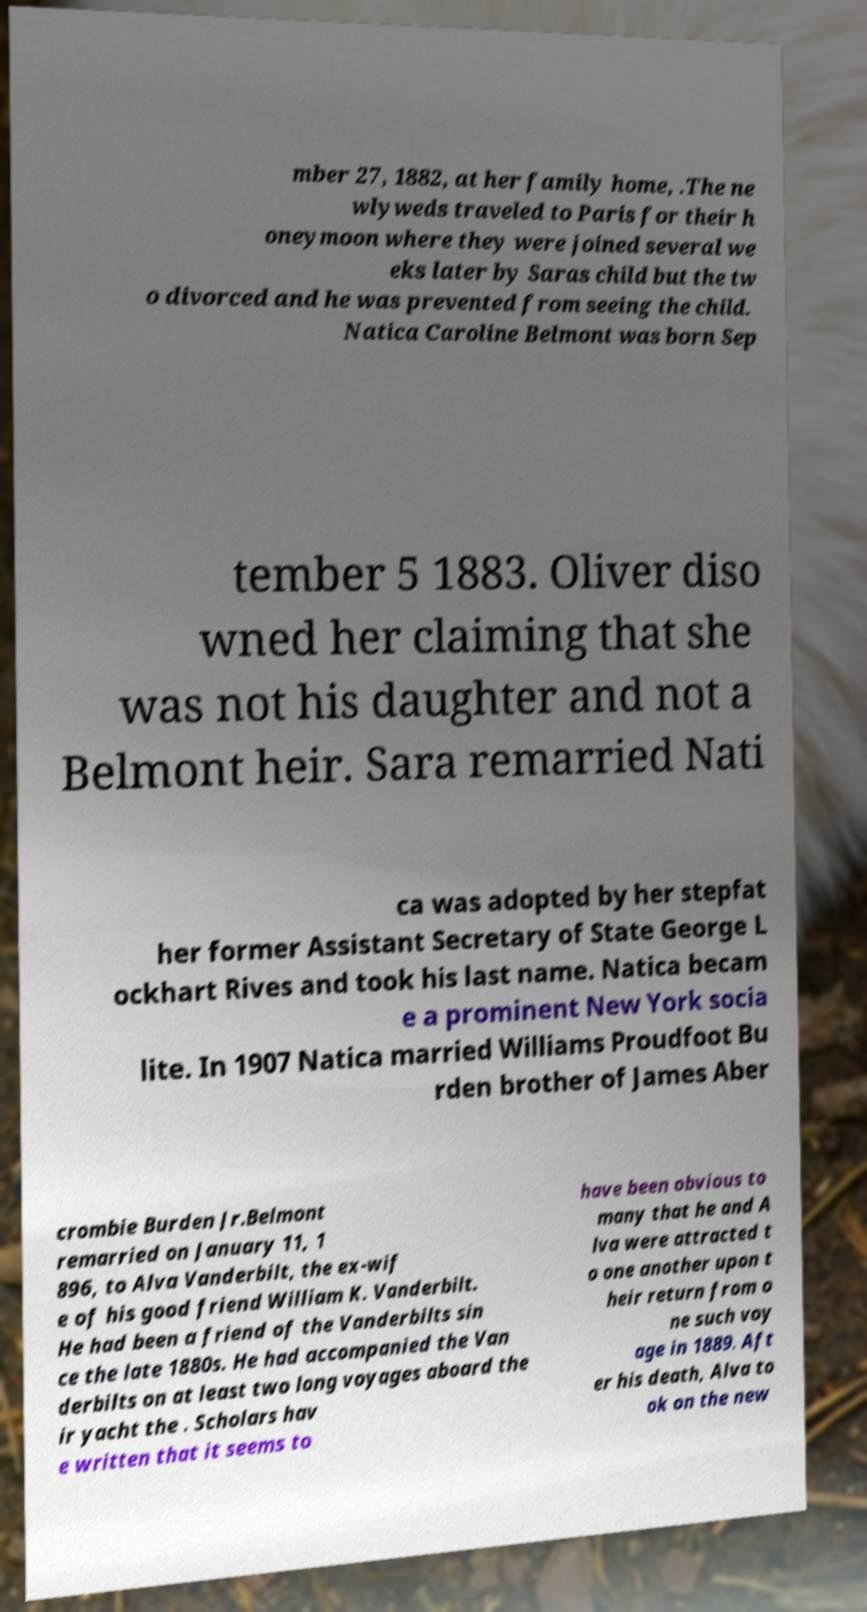Could you extract and type out the text from this image? mber 27, 1882, at her family home, .The ne wlyweds traveled to Paris for their h oneymoon where they were joined several we eks later by Saras child but the tw o divorced and he was prevented from seeing the child. Natica Caroline Belmont was born Sep tember 5 1883. Oliver diso wned her claiming that she was not his daughter and not a Belmont heir. Sara remarried Nati ca was adopted by her stepfat her former Assistant Secretary of State George L ockhart Rives and took his last name. Natica becam e a prominent New York socia lite. In 1907 Natica married Williams Proudfoot Bu rden brother of James Aber crombie Burden Jr.Belmont remarried on January 11, 1 896, to Alva Vanderbilt, the ex-wif e of his good friend William K. Vanderbilt. He had been a friend of the Vanderbilts sin ce the late 1880s. He had accompanied the Van derbilts on at least two long voyages aboard the ir yacht the . Scholars hav e written that it seems to have been obvious to many that he and A lva were attracted t o one another upon t heir return from o ne such voy age in 1889. Aft er his death, Alva to ok on the new 